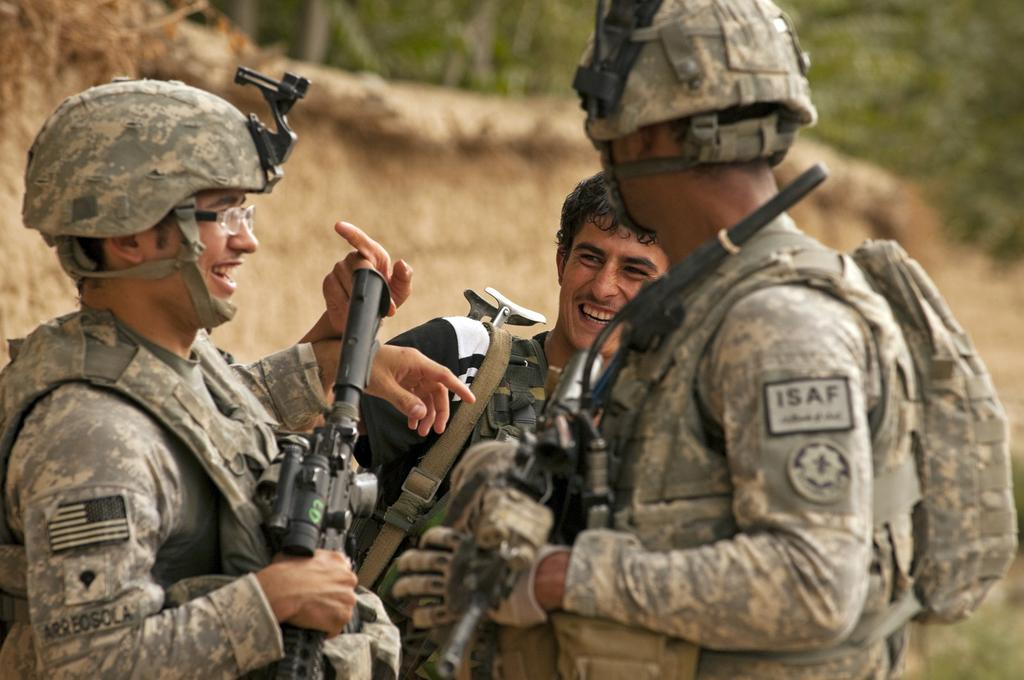How many people are in the image? There are three people in the image. What are the people wearing? The people are wearing uniforms. What expressions do the people have? The people are smiling. What protective gear are two of the people wearing? Two of the people are wearing helmets. What equipment are two of the people carrying? Two of the people are carrying guns. What can be seen in the background of the image? There are trees in the background of the image. What type of amusement park ride can be seen in the image? There is no amusement park ride present in the image. What is the people sorting in the image? The image does not show the people sorting anything. 